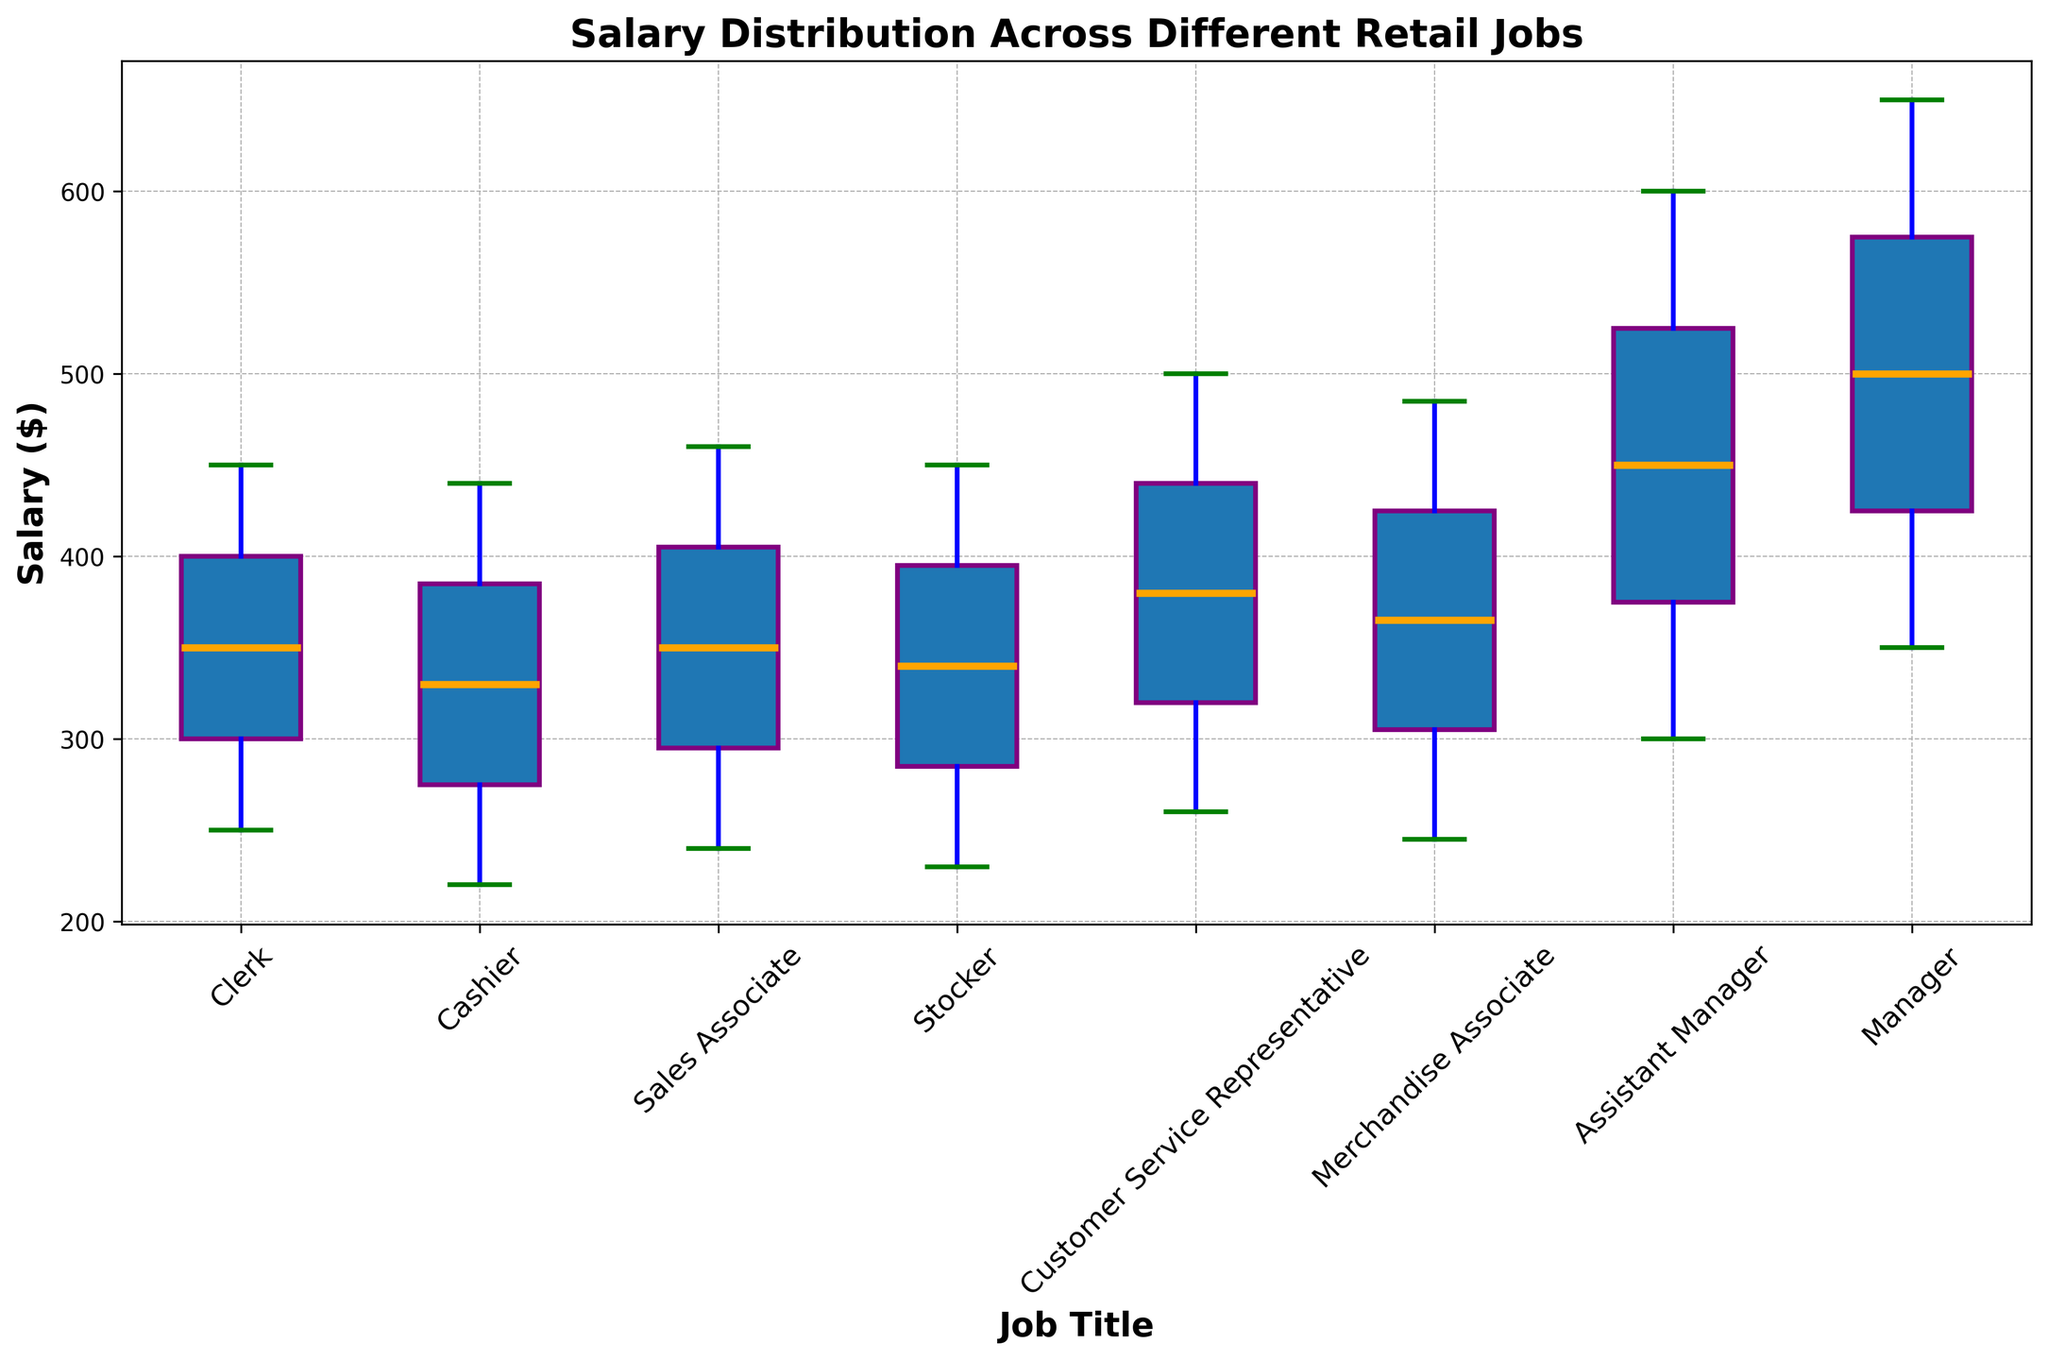Which retail job has the highest median salary? The box plot shows the median salary as the central line within each box. To identify the highest median salary, we compare these central lines across all job titles. The Manager job has the highest median salary as indicated by the orange line.
Answer: Manager How does the median salary of a Clerk compare to that of a Cashier? To compare, we observe the central line within the boxes for both Clerk and Cashier. The median salary for a Clerk is slightly higher than that of a Cashier.
Answer: Clerk is slightly higher What's the range of salaries for a Sales Associate? The salary range is determined by the distance between the upper and lower whiskers of the box plot for Sales Associate. The lower whisker is at $240, and the upper whisker is at $460. Therefore, the range is $460 - $240.
Answer: $220 Which job titles show the widest spread in salary distributions? The spread is understood as the distance between the whiskers. Both the Manager and Assistant Manager job titles have wide spreads, from the lower whisker around $300 to the upper whisker around $650 and from $300 to $600, respectively.
Answer: Manager and Assistant Manager What is the median salary for an Assistant Manager? Identify the orange line within the box for Assistant Manager. This line represents the median, which visually aligns around $450.
Answer: $450 How does the salary spread for a Stocker compare to that of a Customer Service Representative? Compare the length of the whiskers of the box plots for both job titles. The salary spread for a Stocker ranges from $230 to $450, while for a Customer Service Representative, it ranges from $260 to $500. The Customer Service Representative has a wider spread.
Answer: Customer Service Representative is wider Which job has the lowest overall salary, and what is that salary? The lowest overall salary is observed at the bottom whisker of the entire plot. The lowest whisker touches $220 for a Cashier.
Answer: Cashier, $220 Are the salary distributions generally symmetric for these job titles? Check if the median lines are centered within the boxes and if the whiskers are of similar length. Generally, the distributions appear relatively symmetric, with slight variations in balance for a few job titles.
Answer: Generally symmetric How does the median salary of a Manager compare to that of a Merchandise Associate? Observe the orange lines representing the medians for both Manager and Merchandise Associate. The Manager's median salary is higher than that of the Merchandise Associate.
Answer: Manager is higher What's the difference between the highest salary of an Assistant Manager and a Clerk? Identify the upper whisker for each job title. The highest salary for an Assistant Manager is $600, whereas for a Clerk, it is $450. The difference is $600 - $450.
Answer: $150 